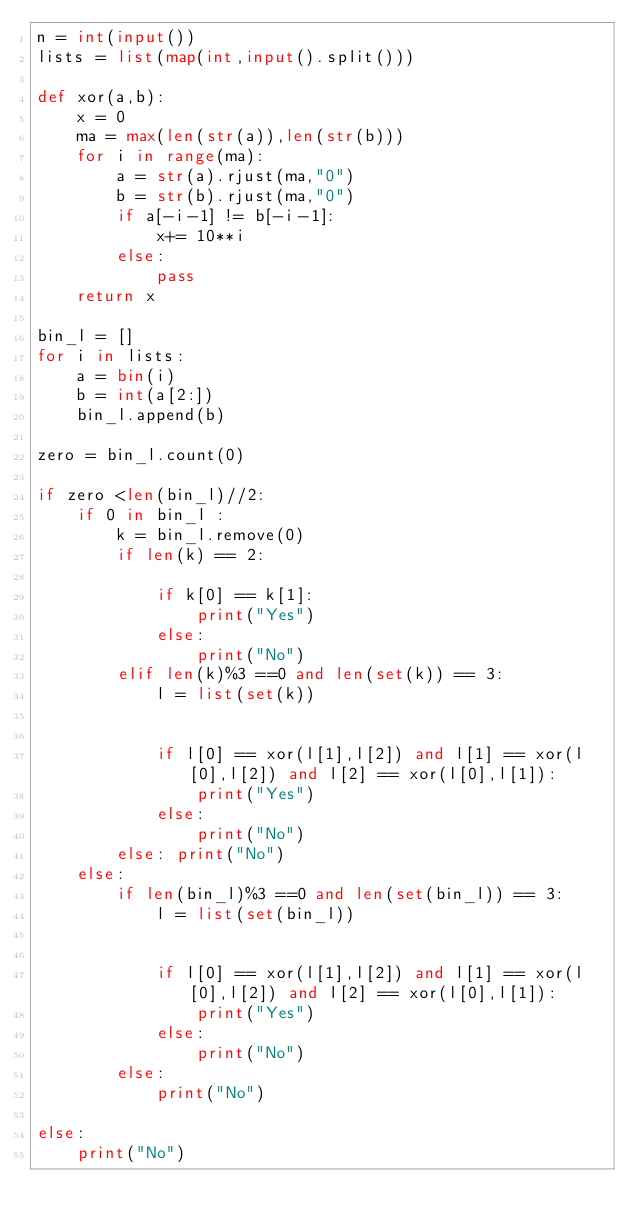<code> <loc_0><loc_0><loc_500><loc_500><_Python_>n = int(input())
lists = list(map(int,input().split()))

def xor(a,b):
    x = 0
    ma = max(len(str(a)),len(str(b)))
    for i in range(ma):
        a = str(a).rjust(ma,"0")
        b = str(b).rjust(ma,"0")     
        if a[-i-1] != b[-i-1]:
            x+= 10**i
        else:
            pass
    return x

bin_l = []
for i in lists:
    a = bin(i)
    b = int(a[2:])
    bin_l.append(b)

zero = bin_l.count(0)

if zero <len(bin_l)//2:
    if 0 in bin_l :
        k = bin_l.remove(0)
        if len(k) == 2:
        
            if k[0] == k[1]:
                print("Yes")
            else:
                print("No")
        elif len(k)%3 ==0 and len(set(k)) == 3:
            l = list(set(k))
    
    
            if l[0] == xor(l[1],l[2]) and l[1] == xor(l[0],l[2]) and l[2] == xor(l[0],l[1]):
                print("Yes")
            else:
                print("No")
        else: print("No")
    else:
        if len(bin_l)%3 ==0 and len(set(bin_l)) == 3:
            l = list(set(bin_l))
    
    
            if l[0] == xor(l[1],l[2]) and l[1] == xor(l[0],l[2]) and l[2] == xor(l[0],l[1]):
                print("Yes")
            else:
                print("No")   
        else:
            print("No")     

else:
    print("No")
</code> 